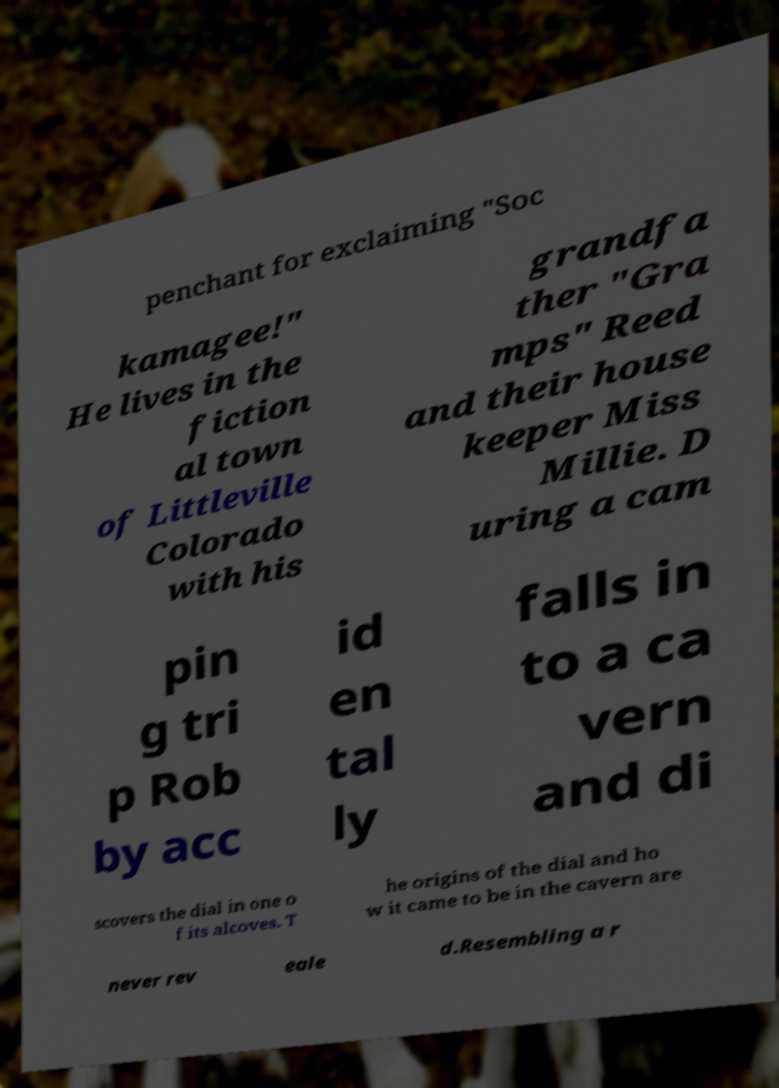Can you read and provide the text displayed in the image?This photo seems to have some interesting text. Can you extract and type it out for me? penchant for exclaiming "Soc kamagee!" He lives in the fiction al town of Littleville Colorado with his grandfa ther "Gra mps" Reed and their house keeper Miss Millie. D uring a cam pin g tri p Rob by acc id en tal ly falls in to a ca vern and di scovers the dial in one o f its alcoves. T he origins of the dial and ho w it came to be in the cavern are never rev eale d.Resembling a r 